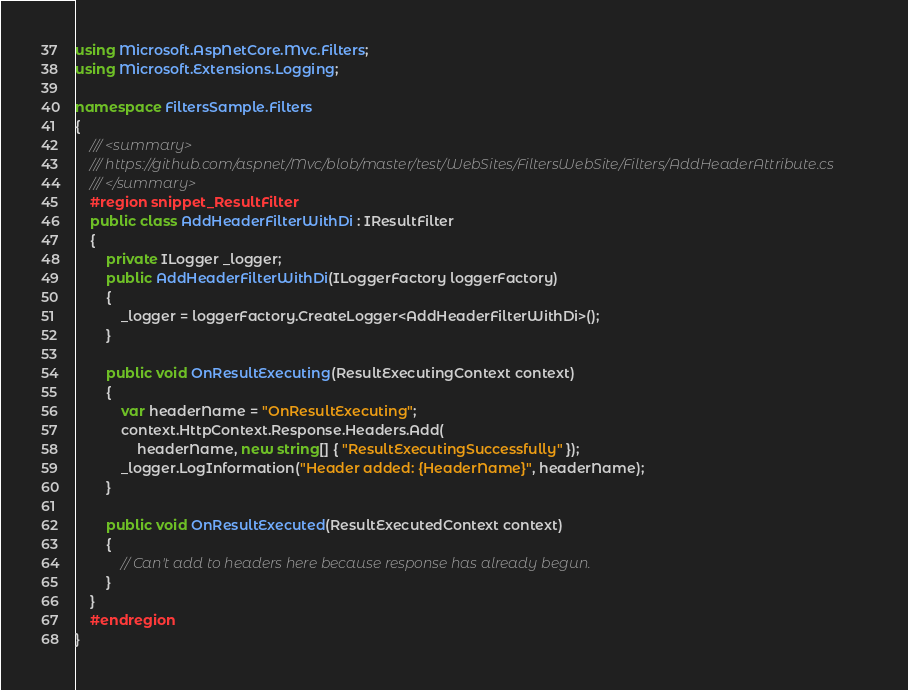Convert code to text. <code><loc_0><loc_0><loc_500><loc_500><_C#_>using Microsoft.AspNetCore.Mvc.Filters;
using Microsoft.Extensions.Logging;

namespace FiltersSample.Filters
{
    /// <summary>
    /// https://github.com/aspnet/Mvc/blob/master/test/WebSites/FiltersWebSite/Filters/AddHeaderAttribute.cs
    /// </summary>
    #region snippet_ResultFilter
    public class AddHeaderFilterWithDi : IResultFilter
    {
        private ILogger _logger;
        public AddHeaderFilterWithDi(ILoggerFactory loggerFactory)
        {
            _logger = loggerFactory.CreateLogger<AddHeaderFilterWithDi>();
        }

        public void OnResultExecuting(ResultExecutingContext context)
        {
            var headerName = "OnResultExecuting";
            context.HttpContext.Response.Headers.Add(
                headerName, new string[] { "ResultExecutingSuccessfully" });
            _logger.LogInformation("Header added: {HeaderName}", headerName);
        }

        public void OnResultExecuted(ResultExecutedContext context)
        {
            // Can't add to headers here because response has already begun.
        }
    }
    #endregion
}</code> 